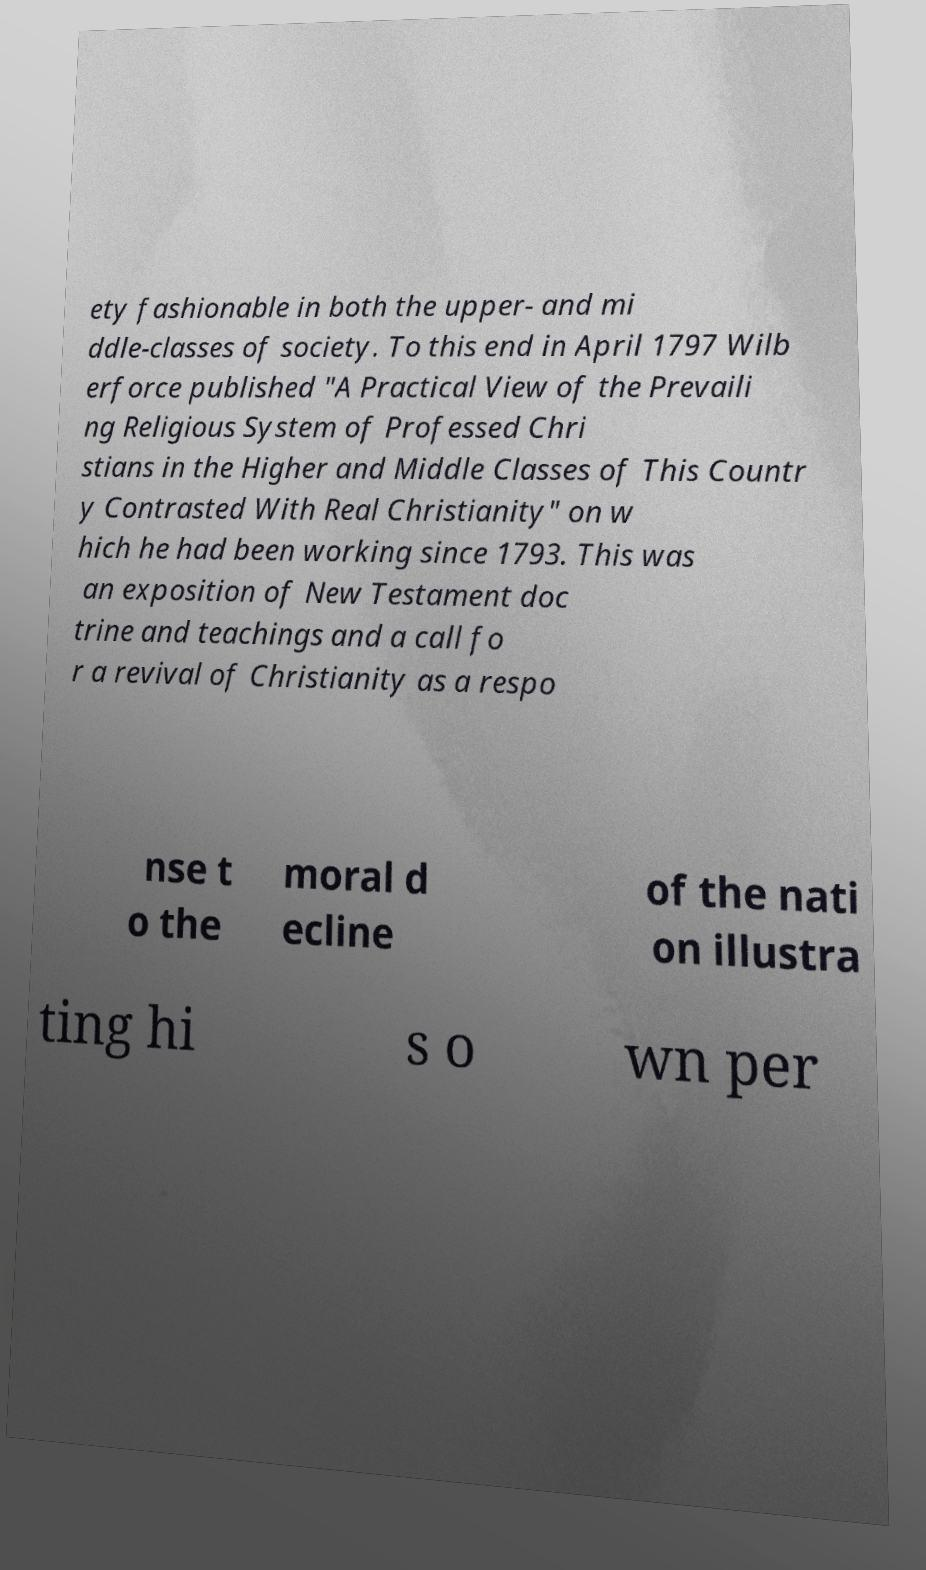For documentation purposes, I need the text within this image transcribed. Could you provide that? ety fashionable in both the upper- and mi ddle-classes of society. To this end in April 1797 Wilb erforce published "A Practical View of the Prevaili ng Religious System of Professed Chri stians in the Higher and Middle Classes of This Countr y Contrasted With Real Christianity" on w hich he had been working since 1793. This was an exposition of New Testament doc trine and teachings and a call fo r a revival of Christianity as a respo nse t o the moral d ecline of the nati on illustra ting hi s o wn per 